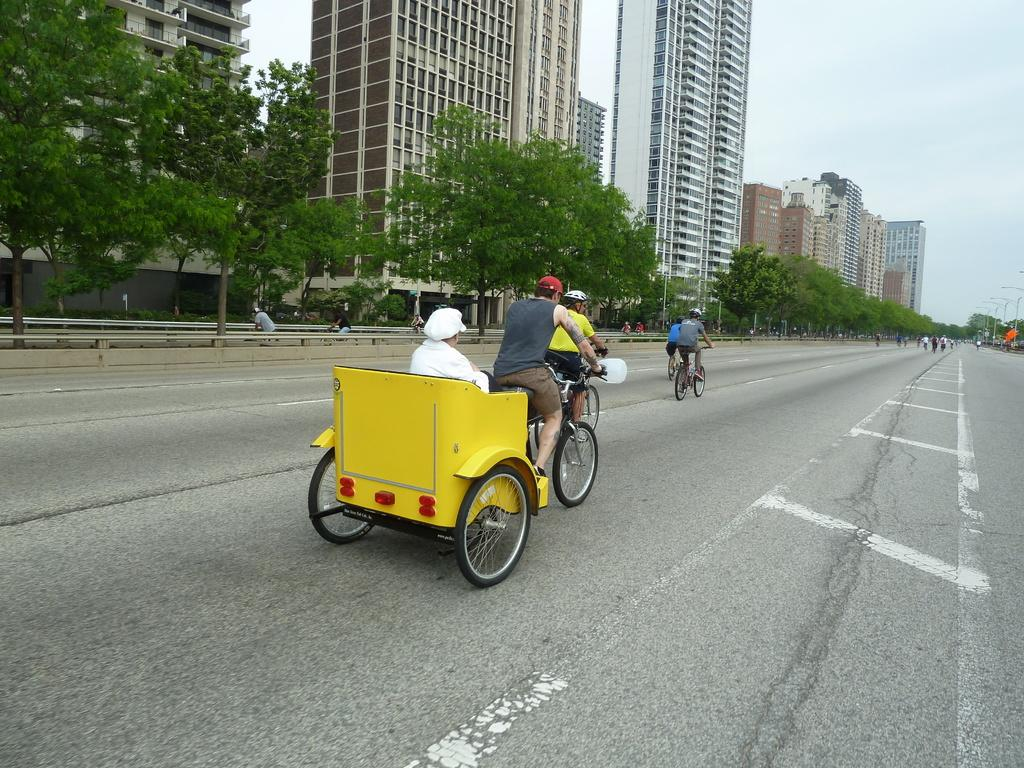What is the man doing in the image? The man is riding a rickshaw in the image. Where is the rickshaw located? The rickshaw is on a road in the image. What can be seen in the image besides the rickshaw and the man? There are trees and big buildings in the background of the image. What time does the clock show in the image? There is no clock present in the image, so it is not possible to determine the time. 